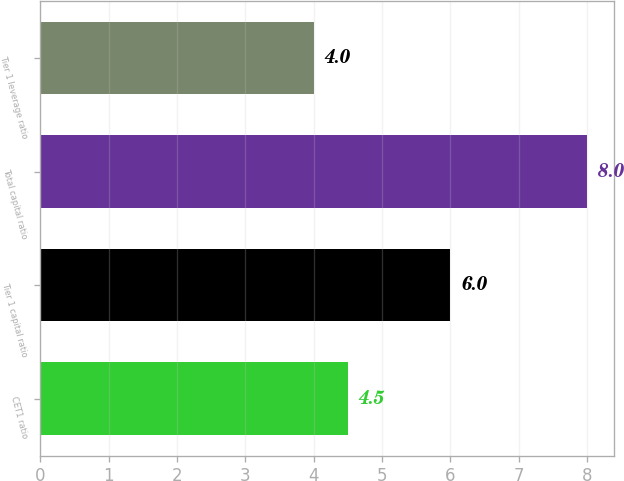<chart> <loc_0><loc_0><loc_500><loc_500><bar_chart><fcel>CET1 ratio<fcel>Tier 1 capital ratio<fcel>Total capital ratio<fcel>Tier 1 leverage ratio<nl><fcel>4.5<fcel>6<fcel>8<fcel>4<nl></chart> 